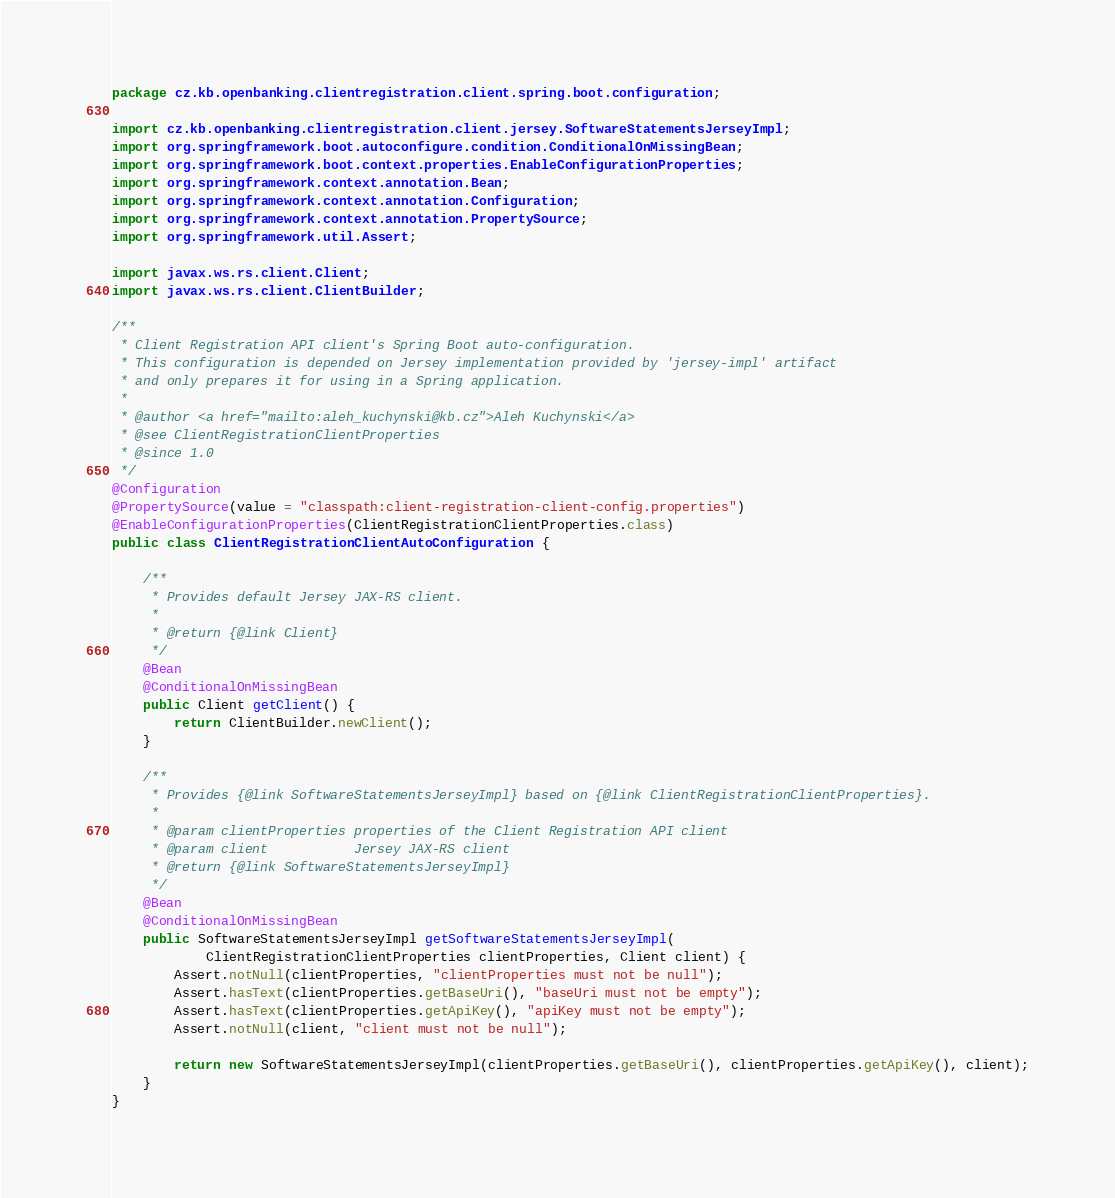Convert code to text. <code><loc_0><loc_0><loc_500><loc_500><_Java_>package cz.kb.openbanking.clientregistration.client.spring.boot.configuration;

import cz.kb.openbanking.clientregistration.client.jersey.SoftwareStatementsJerseyImpl;
import org.springframework.boot.autoconfigure.condition.ConditionalOnMissingBean;
import org.springframework.boot.context.properties.EnableConfigurationProperties;
import org.springframework.context.annotation.Bean;
import org.springframework.context.annotation.Configuration;
import org.springframework.context.annotation.PropertySource;
import org.springframework.util.Assert;

import javax.ws.rs.client.Client;
import javax.ws.rs.client.ClientBuilder;

/**
 * Client Registration API client's Spring Boot auto-configuration.
 * This configuration is depended on Jersey implementation provided by 'jersey-impl' artifact
 * and only prepares it for using in a Spring application.
 *
 * @author <a href="mailto:aleh_kuchynski@kb.cz">Aleh Kuchynski</a>
 * @see ClientRegistrationClientProperties
 * @since 1.0
 */
@Configuration
@PropertySource(value = "classpath:client-registration-client-config.properties")
@EnableConfigurationProperties(ClientRegistrationClientProperties.class)
public class ClientRegistrationClientAutoConfiguration {

    /**
     * Provides default Jersey JAX-RS client.
     *
     * @return {@link Client}
     */
    @Bean
    @ConditionalOnMissingBean
    public Client getClient() {
        return ClientBuilder.newClient();
    }

    /**
     * Provides {@link SoftwareStatementsJerseyImpl} based on {@link ClientRegistrationClientProperties}.
     *
     * @param clientProperties properties of the Client Registration API client
     * @param client           Jersey JAX-RS client
     * @return {@link SoftwareStatementsJerseyImpl}
     */
    @Bean
    @ConditionalOnMissingBean
    public SoftwareStatementsJerseyImpl getSoftwareStatementsJerseyImpl(
            ClientRegistrationClientProperties clientProperties, Client client) {
        Assert.notNull(clientProperties, "clientProperties must not be null");
        Assert.hasText(clientProperties.getBaseUri(), "baseUri must not be empty");
        Assert.hasText(clientProperties.getApiKey(), "apiKey must not be empty");
        Assert.notNull(client, "client must not be null");

        return new SoftwareStatementsJerseyImpl(clientProperties.getBaseUri(), clientProperties.getApiKey(), client);
    }
}
</code> 